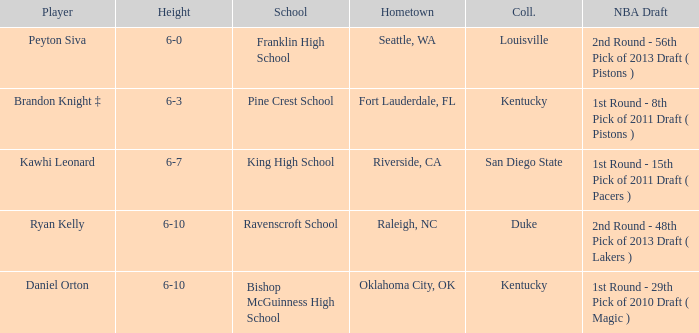Which height is associated with Franklin High School? 6-0. 